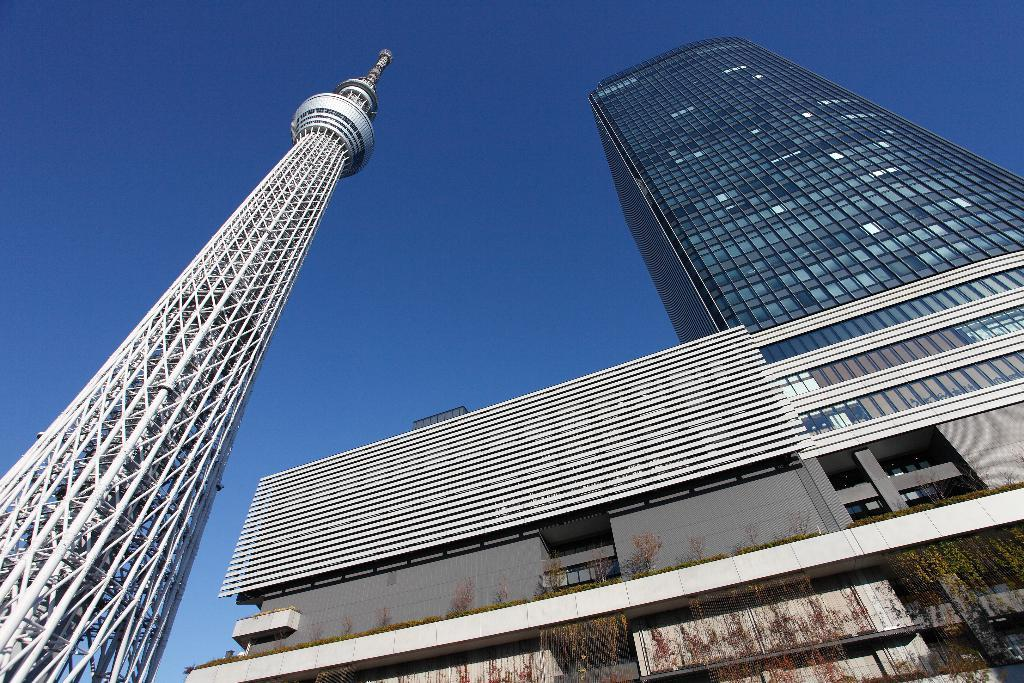What type of structures can be seen in the image? There are buildings and a tower in the image. What else is present in the image besides the structures? There are plants in the image. What color is the sky in the background of the image? The sky is blue in the background of the image. What type of cloth is being used to clean the tower in the image? There is no cloth or cleaning activity depicted in the image; it only shows the buildings, tower, plants, and blue sky. 